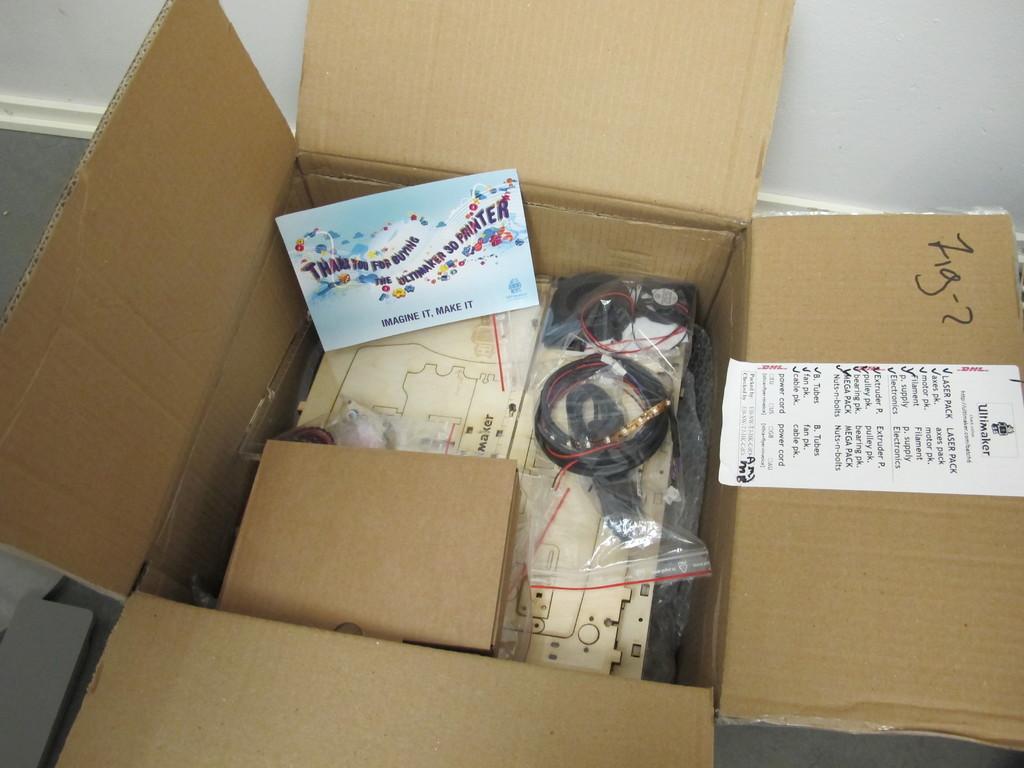What's the slogan on the bottom of the card?
Your answer should be very brief. Imagine it, make it. What is written on sharpie on the right side of the box?
Offer a very short reply. Zig-2. 